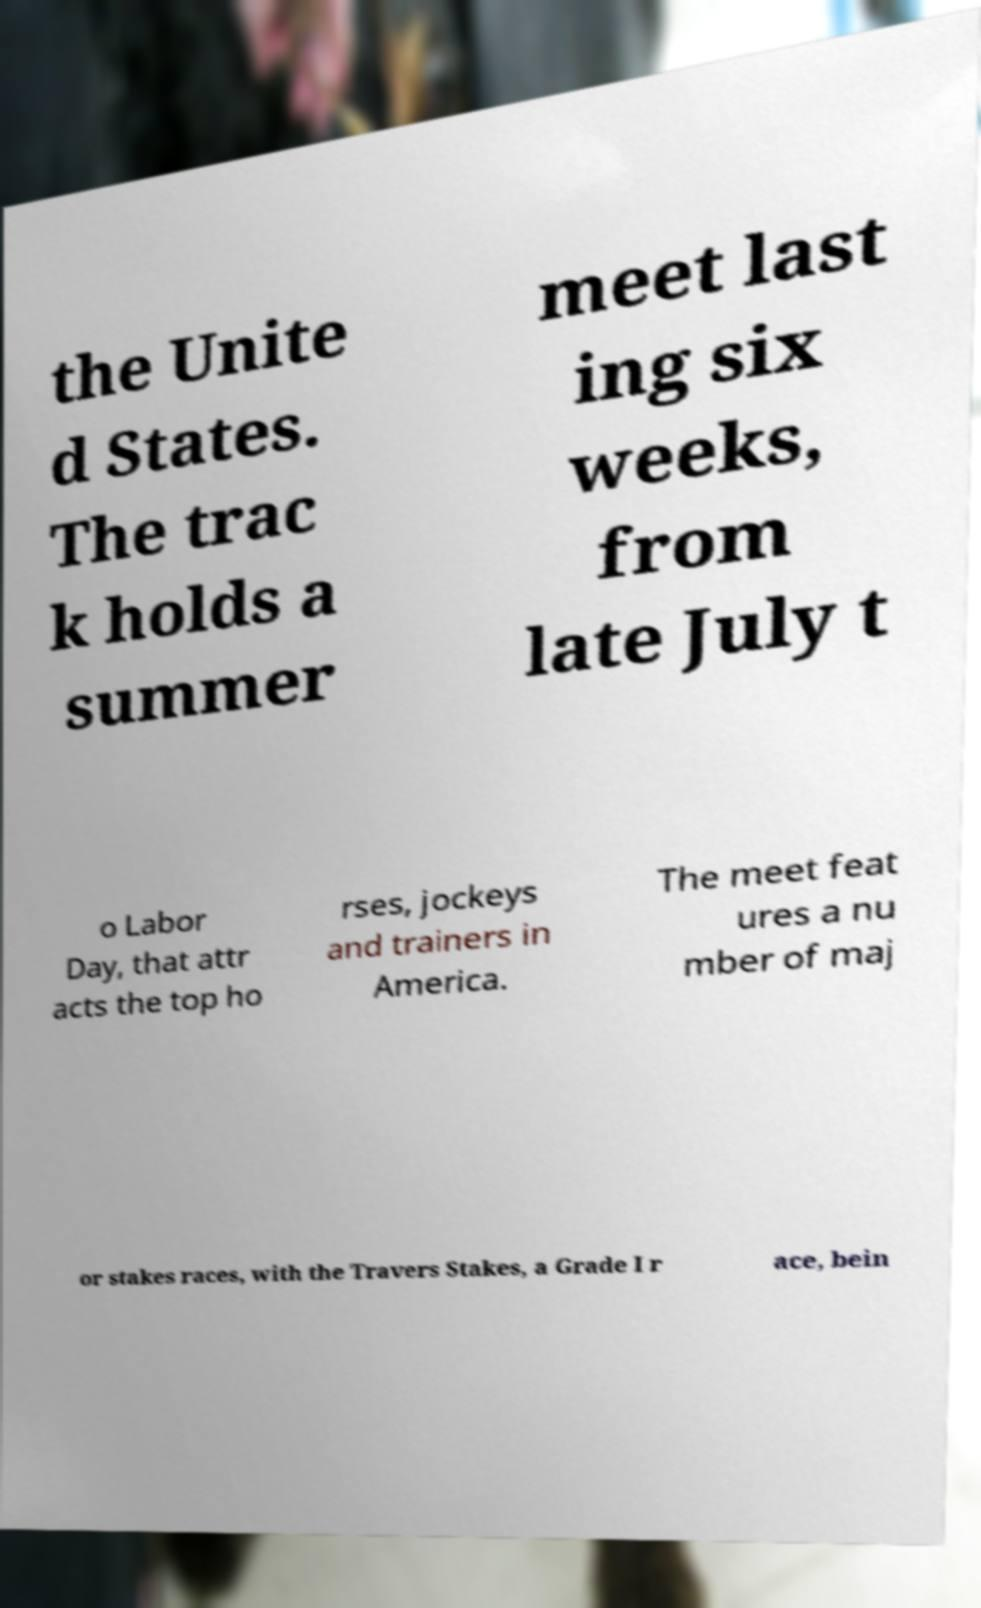I need the written content from this picture converted into text. Can you do that? the Unite d States. The trac k holds a summer meet last ing six weeks, from late July t o Labor Day, that attr acts the top ho rses, jockeys and trainers in America. The meet feat ures a nu mber of maj or stakes races, with the Travers Stakes, a Grade I r ace, bein 